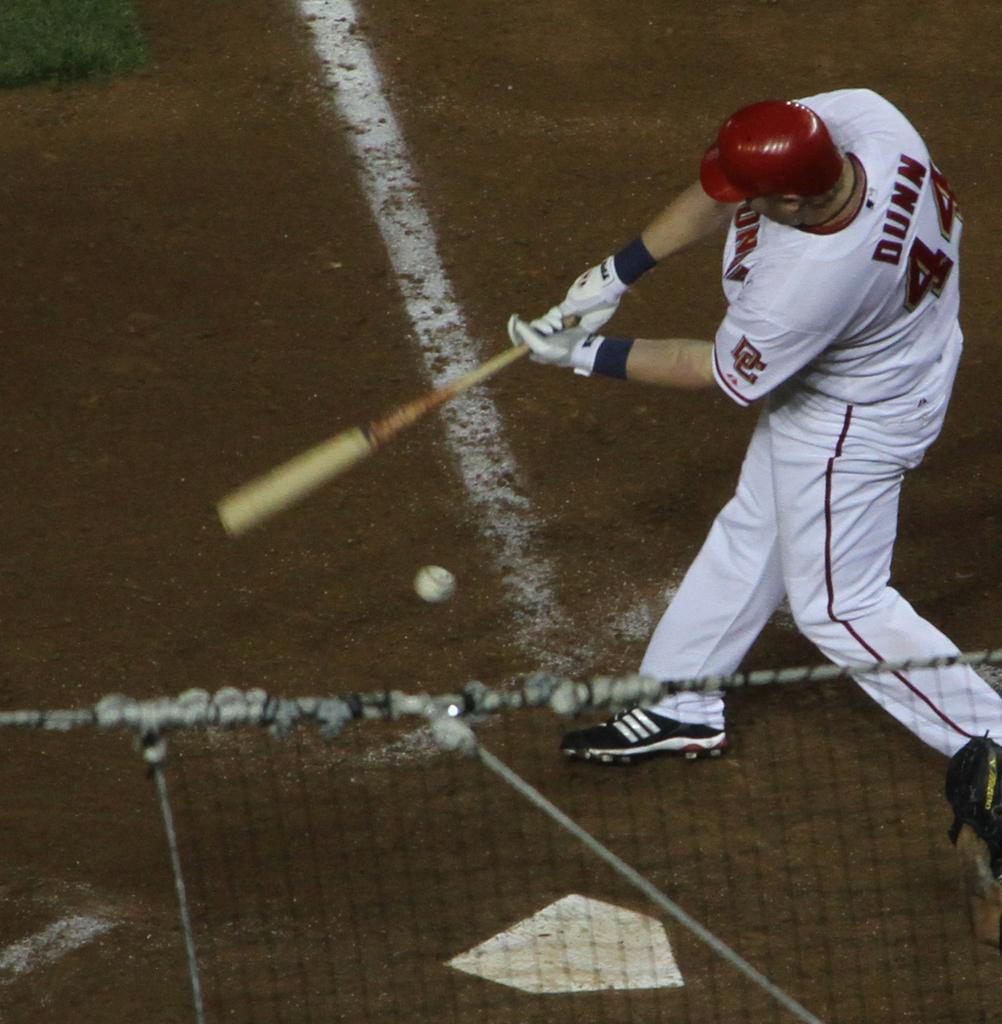<image>
Write a terse but informative summary of the picture. Number 44 batter Dunn misses the ball with his swing. 